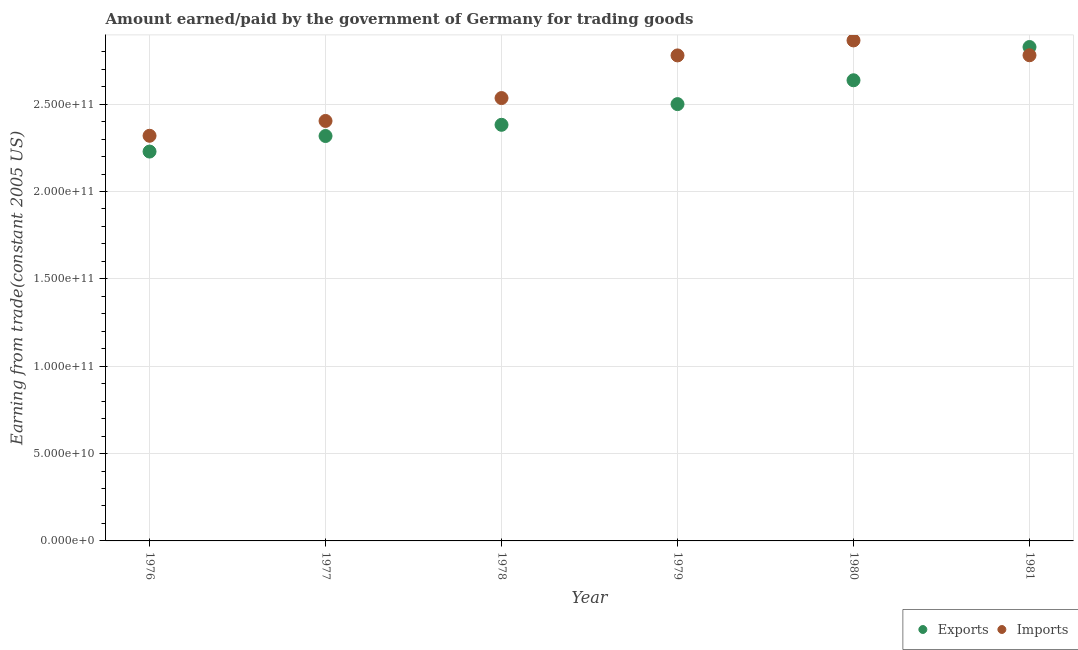How many different coloured dotlines are there?
Make the answer very short. 2. Is the number of dotlines equal to the number of legend labels?
Offer a very short reply. Yes. What is the amount earned from exports in 1977?
Your answer should be compact. 2.32e+11. Across all years, what is the maximum amount paid for imports?
Offer a very short reply. 2.86e+11. Across all years, what is the minimum amount paid for imports?
Your answer should be very brief. 2.32e+11. In which year was the amount earned from exports minimum?
Your answer should be compact. 1976. What is the total amount paid for imports in the graph?
Make the answer very short. 1.57e+12. What is the difference between the amount paid for imports in 1976 and that in 1979?
Your answer should be compact. -4.60e+1. What is the difference between the amount paid for imports in 1979 and the amount earned from exports in 1980?
Your response must be concise. 1.42e+1. What is the average amount paid for imports per year?
Your answer should be very brief. 2.61e+11. In the year 1976, what is the difference between the amount earned from exports and amount paid for imports?
Your answer should be compact. -9.04e+09. In how many years, is the amount paid for imports greater than 260000000000 US$?
Your answer should be very brief. 3. What is the ratio of the amount earned from exports in 1978 to that in 1980?
Keep it short and to the point. 0.9. What is the difference between the highest and the second highest amount earned from exports?
Provide a succinct answer. 1.90e+1. What is the difference between the highest and the lowest amount earned from exports?
Keep it short and to the point. 5.98e+1. In how many years, is the amount earned from exports greater than the average amount earned from exports taken over all years?
Make the answer very short. 3. Does the amount paid for imports monotonically increase over the years?
Offer a very short reply. No. Is the amount earned from exports strictly greater than the amount paid for imports over the years?
Make the answer very short. No. How many dotlines are there?
Your answer should be very brief. 2. Are the values on the major ticks of Y-axis written in scientific E-notation?
Your answer should be compact. Yes. Does the graph contain any zero values?
Provide a succinct answer. No. Where does the legend appear in the graph?
Your answer should be compact. Bottom right. What is the title of the graph?
Provide a succinct answer. Amount earned/paid by the government of Germany for trading goods. Does "National Tourists" appear as one of the legend labels in the graph?
Provide a succinct answer. No. What is the label or title of the X-axis?
Your response must be concise. Year. What is the label or title of the Y-axis?
Your answer should be compact. Earning from trade(constant 2005 US). What is the Earning from trade(constant 2005 US) of Exports in 1976?
Your answer should be compact. 2.23e+11. What is the Earning from trade(constant 2005 US) in Imports in 1976?
Your answer should be compact. 2.32e+11. What is the Earning from trade(constant 2005 US) of Exports in 1977?
Your answer should be compact. 2.32e+11. What is the Earning from trade(constant 2005 US) in Imports in 1977?
Your answer should be very brief. 2.40e+11. What is the Earning from trade(constant 2005 US) of Exports in 1978?
Offer a very short reply. 2.38e+11. What is the Earning from trade(constant 2005 US) in Imports in 1978?
Provide a short and direct response. 2.53e+11. What is the Earning from trade(constant 2005 US) in Exports in 1979?
Keep it short and to the point. 2.50e+11. What is the Earning from trade(constant 2005 US) in Imports in 1979?
Keep it short and to the point. 2.78e+11. What is the Earning from trade(constant 2005 US) of Exports in 1980?
Give a very brief answer. 2.64e+11. What is the Earning from trade(constant 2005 US) of Imports in 1980?
Offer a very short reply. 2.86e+11. What is the Earning from trade(constant 2005 US) in Exports in 1981?
Keep it short and to the point. 2.83e+11. What is the Earning from trade(constant 2005 US) in Imports in 1981?
Your answer should be very brief. 2.78e+11. Across all years, what is the maximum Earning from trade(constant 2005 US) of Exports?
Ensure brevity in your answer.  2.83e+11. Across all years, what is the maximum Earning from trade(constant 2005 US) in Imports?
Offer a very short reply. 2.86e+11. Across all years, what is the minimum Earning from trade(constant 2005 US) in Exports?
Provide a short and direct response. 2.23e+11. Across all years, what is the minimum Earning from trade(constant 2005 US) in Imports?
Give a very brief answer. 2.32e+11. What is the total Earning from trade(constant 2005 US) in Exports in the graph?
Keep it short and to the point. 1.49e+12. What is the total Earning from trade(constant 2005 US) in Imports in the graph?
Make the answer very short. 1.57e+12. What is the difference between the Earning from trade(constant 2005 US) in Exports in 1976 and that in 1977?
Offer a very short reply. -8.90e+09. What is the difference between the Earning from trade(constant 2005 US) of Imports in 1976 and that in 1977?
Keep it short and to the point. -8.48e+09. What is the difference between the Earning from trade(constant 2005 US) of Exports in 1976 and that in 1978?
Provide a short and direct response. -1.53e+1. What is the difference between the Earning from trade(constant 2005 US) of Imports in 1976 and that in 1978?
Keep it short and to the point. -2.16e+1. What is the difference between the Earning from trade(constant 2005 US) of Exports in 1976 and that in 1979?
Provide a succinct answer. -2.72e+1. What is the difference between the Earning from trade(constant 2005 US) of Imports in 1976 and that in 1979?
Provide a short and direct response. -4.60e+1. What is the difference between the Earning from trade(constant 2005 US) of Exports in 1976 and that in 1980?
Make the answer very short. -4.08e+1. What is the difference between the Earning from trade(constant 2005 US) in Imports in 1976 and that in 1980?
Offer a very short reply. -5.46e+1. What is the difference between the Earning from trade(constant 2005 US) of Exports in 1976 and that in 1981?
Make the answer very short. -5.98e+1. What is the difference between the Earning from trade(constant 2005 US) of Imports in 1976 and that in 1981?
Provide a succinct answer. -4.61e+1. What is the difference between the Earning from trade(constant 2005 US) in Exports in 1977 and that in 1978?
Your answer should be compact. -6.41e+09. What is the difference between the Earning from trade(constant 2005 US) in Imports in 1977 and that in 1978?
Keep it short and to the point. -1.31e+1. What is the difference between the Earning from trade(constant 2005 US) of Exports in 1977 and that in 1979?
Make the answer very short. -1.82e+1. What is the difference between the Earning from trade(constant 2005 US) in Imports in 1977 and that in 1979?
Provide a short and direct response. -3.75e+1. What is the difference between the Earning from trade(constant 2005 US) in Exports in 1977 and that in 1980?
Offer a very short reply. -3.19e+1. What is the difference between the Earning from trade(constant 2005 US) of Imports in 1977 and that in 1980?
Your answer should be compact. -4.61e+1. What is the difference between the Earning from trade(constant 2005 US) in Exports in 1977 and that in 1981?
Provide a succinct answer. -5.09e+1. What is the difference between the Earning from trade(constant 2005 US) in Imports in 1977 and that in 1981?
Provide a succinct answer. -3.76e+1. What is the difference between the Earning from trade(constant 2005 US) in Exports in 1978 and that in 1979?
Provide a succinct answer. -1.18e+1. What is the difference between the Earning from trade(constant 2005 US) in Imports in 1978 and that in 1979?
Give a very brief answer. -2.44e+1. What is the difference between the Earning from trade(constant 2005 US) in Exports in 1978 and that in 1980?
Offer a terse response. -2.55e+1. What is the difference between the Earning from trade(constant 2005 US) of Imports in 1978 and that in 1980?
Provide a short and direct response. -3.30e+1. What is the difference between the Earning from trade(constant 2005 US) of Exports in 1978 and that in 1981?
Make the answer very short. -4.45e+1. What is the difference between the Earning from trade(constant 2005 US) of Imports in 1978 and that in 1981?
Your response must be concise. -2.45e+1. What is the difference between the Earning from trade(constant 2005 US) of Exports in 1979 and that in 1980?
Give a very brief answer. -1.37e+1. What is the difference between the Earning from trade(constant 2005 US) in Imports in 1979 and that in 1980?
Make the answer very short. -8.58e+09. What is the difference between the Earning from trade(constant 2005 US) of Exports in 1979 and that in 1981?
Make the answer very short. -3.27e+1. What is the difference between the Earning from trade(constant 2005 US) in Imports in 1979 and that in 1981?
Keep it short and to the point. -9.43e+07. What is the difference between the Earning from trade(constant 2005 US) in Exports in 1980 and that in 1981?
Your answer should be very brief. -1.90e+1. What is the difference between the Earning from trade(constant 2005 US) in Imports in 1980 and that in 1981?
Your response must be concise. 8.48e+09. What is the difference between the Earning from trade(constant 2005 US) in Exports in 1976 and the Earning from trade(constant 2005 US) in Imports in 1977?
Keep it short and to the point. -1.75e+1. What is the difference between the Earning from trade(constant 2005 US) of Exports in 1976 and the Earning from trade(constant 2005 US) of Imports in 1978?
Offer a terse response. -3.06e+1. What is the difference between the Earning from trade(constant 2005 US) in Exports in 1976 and the Earning from trade(constant 2005 US) in Imports in 1979?
Offer a very short reply. -5.50e+1. What is the difference between the Earning from trade(constant 2005 US) of Exports in 1976 and the Earning from trade(constant 2005 US) of Imports in 1980?
Offer a terse response. -6.36e+1. What is the difference between the Earning from trade(constant 2005 US) in Exports in 1976 and the Earning from trade(constant 2005 US) in Imports in 1981?
Offer a very short reply. -5.51e+1. What is the difference between the Earning from trade(constant 2005 US) in Exports in 1977 and the Earning from trade(constant 2005 US) in Imports in 1978?
Your answer should be compact. -2.17e+1. What is the difference between the Earning from trade(constant 2005 US) of Exports in 1977 and the Earning from trade(constant 2005 US) of Imports in 1979?
Ensure brevity in your answer.  -4.61e+1. What is the difference between the Earning from trade(constant 2005 US) of Exports in 1977 and the Earning from trade(constant 2005 US) of Imports in 1980?
Keep it short and to the point. -5.47e+1. What is the difference between the Earning from trade(constant 2005 US) of Exports in 1977 and the Earning from trade(constant 2005 US) of Imports in 1981?
Provide a succinct answer. -4.62e+1. What is the difference between the Earning from trade(constant 2005 US) in Exports in 1978 and the Earning from trade(constant 2005 US) in Imports in 1979?
Offer a very short reply. -3.97e+1. What is the difference between the Earning from trade(constant 2005 US) in Exports in 1978 and the Earning from trade(constant 2005 US) in Imports in 1980?
Provide a short and direct response. -4.83e+1. What is the difference between the Earning from trade(constant 2005 US) in Exports in 1978 and the Earning from trade(constant 2005 US) in Imports in 1981?
Your answer should be compact. -3.98e+1. What is the difference between the Earning from trade(constant 2005 US) of Exports in 1979 and the Earning from trade(constant 2005 US) of Imports in 1980?
Offer a terse response. -3.65e+1. What is the difference between the Earning from trade(constant 2005 US) in Exports in 1979 and the Earning from trade(constant 2005 US) in Imports in 1981?
Offer a terse response. -2.80e+1. What is the difference between the Earning from trade(constant 2005 US) in Exports in 1980 and the Earning from trade(constant 2005 US) in Imports in 1981?
Your response must be concise. -1.43e+1. What is the average Earning from trade(constant 2005 US) in Exports per year?
Provide a short and direct response. 2.48e+11. What is the average Earning from trade(constant 2005 US) of Imports per year?
Offer a terse response. 2.61e+11. In the year 1976, what is the difference between the Earning from trade(constant 2005 US) in Exports and Earning from trade(constant 2005 US) in Imports?
Give a very brief answer. -9.04e+09. In the year 1977, what is the difference between the Earning from trade(constant 2005 US) in Exports and Earning from trade(constant 2005 US) in Imports?
Your answer should be compact. -8.61e+09. In the year 1978, what is the difference between the Earning from trade(constant 2005 US) in Exports and Earning from trade(constant 2005 US) in Imports?
Offer a very short reply. -1.53e+1. In the year 1979, what is the difference between the Earning from trade(constant 2005 US) of Exports and Earning from trade(constant 2005 US) of Imports?
Offer a terse response. -2.79e+1. In the year 1980, what is the difference between the Earning from trade(constant 2005 US) of Exports and Earning from trade(constant 2005 US) of Imports?
Offer a very short reply. -2.28e+1. In the year 1981, what is the difference between the Earning from trade(constant 2005 US) in Exports and Earning from trade(constant 2005 US) in Imports?
Give a very brief answer. 4.71e+09. What is the ratio of the Earning from trade(constant 2005 US) of Exports in 1976 to that in 1977?
Keep it short and to the point. 0.96. What is the ratio of the Earning from trade(constant 2005 US) of Imports in 1976 to that in 1977?
Your answer should be compact. 0.96. What is the ratio of the Earning from trade(constant 2005 US) in Exports in 1976 to that in 1978?
Ensure brevity in your answer.  0.94. What is the ratio of the Earning from trade(constant 2005 US) of Imports in 1976 to that in 1978?
Keep it short and to the point. 0.91. What is the ratio of the Earning from trade(constant 2005 US) in Exports in 1976 to that in 1979?
Your answer should be very brief. 0.89. What is the ratio of the Earning from trade(constant 2005 US) in Imports in 1976 to that in 1979?
Give a very brief answer. 0.83. What is the ratio of the Earning from trade(constant 2005 US) in Exports in 1976 to that in 1980?
Your response must be concise. 0.85. What is the ratio of the Earning from trade(constant 2005 US) of Imports in 1976 to that in 1980?
Keep it short and to the point. 0.81. What is the ratio of the Earning from trade(constant 2005 US) of Exports in 1976 to that in 1981?
Keep it short and to the point. 0.79. What is the ratio of the Earning from trade(constant 2005 US) of Imports in 1976 to that in 1981?
Ensure brevity in your answer.  0.83. What is the ratio of the Earning from trade(constant 2005 US) in Exports in 1977 to that in 1978?
Provide a short and direct response. 0.97. What is the ratio of the Earning from trade(constant 2005 US) of Imports in 1977 to that in 1978?
Offer a very short reply. 0.95. What is the ratio of the Earning from trade(constant 2005 US) of Exports in 1977 to that in 1979?
Provide a short and direct response. 0.93. What is the ratio of the Earning from trade(constant 2005 US) in Imports in 1977 to that in 1979?
Offer a very short reply. 0.86. What is the ratio of the Earning from trade(constant 2005 US) in Exports in 1977 to that in 1980?
Your answer should be compact. 0.88. What is the ratio of the Earning from trade(constant 2005 US) in Imports in 1977 to that in 1980?
Your answer should be very brief. 0.84. What is the ratio of the Earning from trade(constant 2005 US) in Exports in 1977 to that in 1981?
Your response must be concise. 0.82. What is the ratio of the Earning from trade(constant 2005 US) in Imports in 1977 to that in 1981?
Provide a short and direct response. 0.86. What is the ratio of the Earning from trade(constant 2005 US) in Exports in 1978 to that in 1979?
Ensure brevity in your answer.  0.95. What is the ratio of the Earning from trade(constant 2005 US) in Imports in 1978 to that in 1979?
Provide a short and direct response. 0.91. What is the ratio of the Earning from trade(constant 2005 US) of Exports in 1978 to that in 1980?
Give a very brief answer. 0.9. What is the ratio of the Earning from trade(constant 2005 US) of Imports in 1978 to that in 1980?
Provide a short and direct response. 0.88. What is the ratio of the Earning from trade(constant 2005 US) in Exports in 1978 to that in 1981?
Give a very brief answer. 0.84. What is the ratio of the Earning from trade(constant 2005 US) in Imports in 1978 to that in 1981?
Your answer should be very brief. 0.91. What is the ratio of the Earning from trade(constant 2005 US) of Exports in 1979 to that in 1980?
Your answer should be very brief. 0.95. What is the ratio of the Earning from trade(constant 2005 US) of Imports in 1979 to that in 1980?
Your response must be concise. 0.97. What is the ratio of the Earning from trade(constant 2005 US) in Exports in 1979 to that in 1981?
Provide a succinct answer. 0.88. What is the ratio of the Earning from trade(constant 2005 US) in Imports in 1979 to that in 1981?
Ensure brevity in your answer.  1. What is the ratio of the Earning from trade(constant 2005 US) of Exports in 1980 to that in 1981?
Your answer should be compact. 0.93. What is the ratio of the Earning from trade(constant 2005 US) of Imports in 1980 to that in 1981?
Provide a short and direct response. 1.03. What is the difference between the highest and the second highest Earning from trade(constant 2005 US) of Exports?
Your response must be concise. 1.90e+1. What is the difference between the highest and the second highest Earning from trade(constant 2005 US) in Imports?
Your answer should be compact. 8.48e+09. What is the difference between the highest and the lowest Earning from trade(constant 2005 US) of Exports?
Make the answer very short. 5.98e+1. What is the difference between the highest and the lowest Earning from trade(constant 2005 US) of Imports?
Offer a terse response. 5.46e+1. 